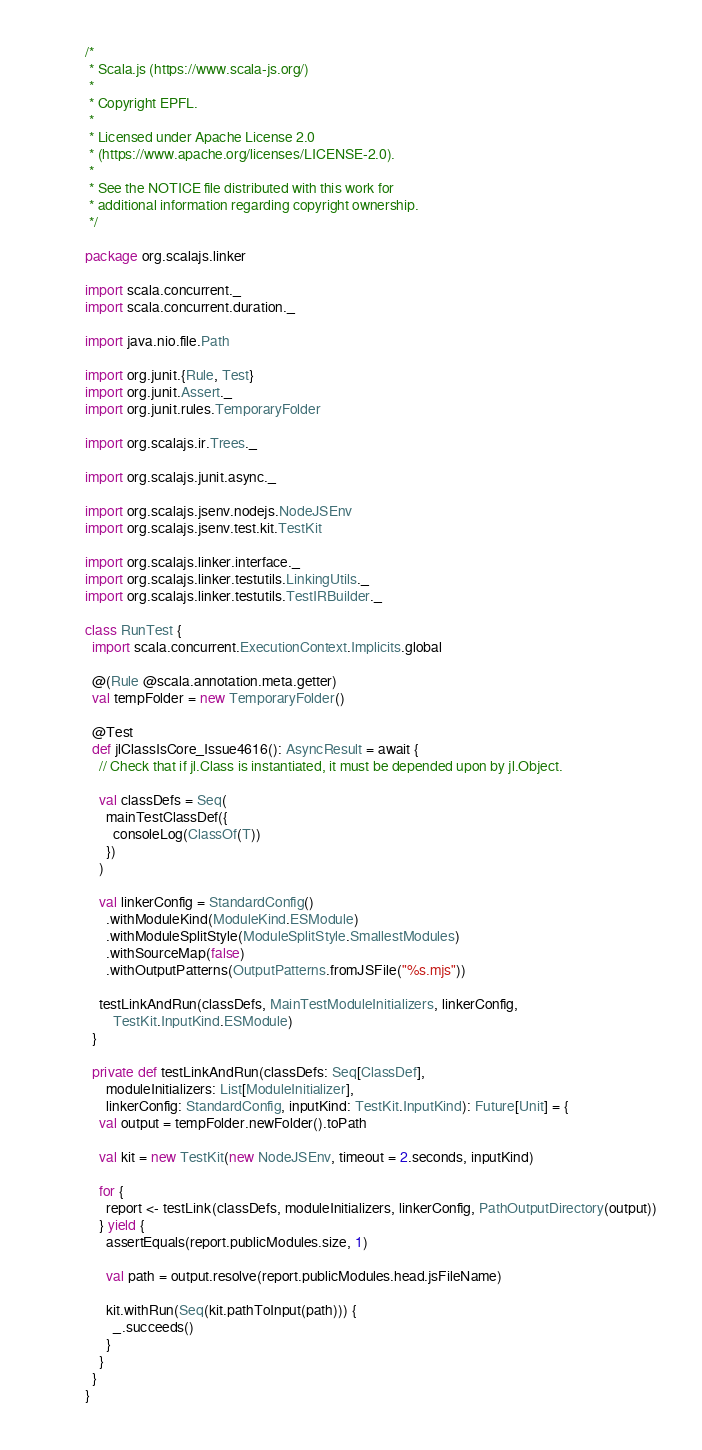Convert code to text. <code><loc_0><loc_0><loc_500><loc_500><_Scala_>/*
 * Scala.js (https://www.scala-js.org/)
 *
 * Copyright EPFL.
 *
 * Licensed under Apache License 2.0
 * (https://www.apache.org/licenses/LICENSE-2.0).
 *
 * See the NOTICE file distributed with this work for
 * additional information regarding copyright ownership.
 */

package org.scalajs.linker

import scala.concurrent._
import scala.concurrent.duration._

import java.nio.file.Path

import org.junit.{Rule, Test}
import org.junit.Assert._
import org.junit.rules.TemporaryFolder

import org.scalajs.ir.Trees._

import org.scalajs.junit.async._

import org.scalajs.jsenv.nodejs.NodeJSEnv
import org.scalajs.jsenv.test.kit.TestKit

import org.scalajs.linker.interface._
import org.scalajs.linker.testutils.LinkingUtils._
import org.scalajs.linker.testutils.TestIRBuilder._

class RunTest {
  import scala.concurrent.ExecutionContext.Implicits.global

  @(Rule @scala.annotation.meta.getter)
  val tempFolder = new TemporaryFolder()

  @Test
  def jlClassIsCore_Issue4616(): AsyncResult = await {
    // Check that if jl.Class is instantiated, it must be depended upon by jl.Object.

    val classDefs = Seq(
      mainTestClassDef({
        consoleLog(ClassOf(T))
      })
    )

    val linkerConfig = StandardConfig()
      .withModuleKind(ModuleKind.ESModule)
      .withModuleSplitStyle(ModuleSplitStyle.SmallestModules)
      .withSourceMap(false)
      .withOutputPatterns(OutputPatterns.fromJSFile("%s.mjs"))

    testLinkAndRun(classDefs, MainTestModuleInitializers, linkerConfig,
        TestKit.InputKind.ESModule)
  }

  private def testLinkAndRun(classDefs: Seq[ClassDef],
      moduleInitializers: List[ModuleInitializer],
      linkerConfig: StandardConfig, inputKind: TestKit.InputKind): Future[Unit] = {
    val output = tempFolder.newFolder().toPath

    val kit = new TestKit(new NodeJSEnv, timeout = 2.seconds, inputKind)

    for {
      report <- testLink(classDefs, moduleInitializers, linkerConfig, PathOutputDirectory(output))
    } yield {
      assertEquals(report.publicModules.size, 1)

      val path = output.resolve(report.publicModules.head.jsFileName)

      kit.withRun(Seq(kit.pathToInput(path))) {
        _.succeeds()
      }
    }
  }
}
</code> 